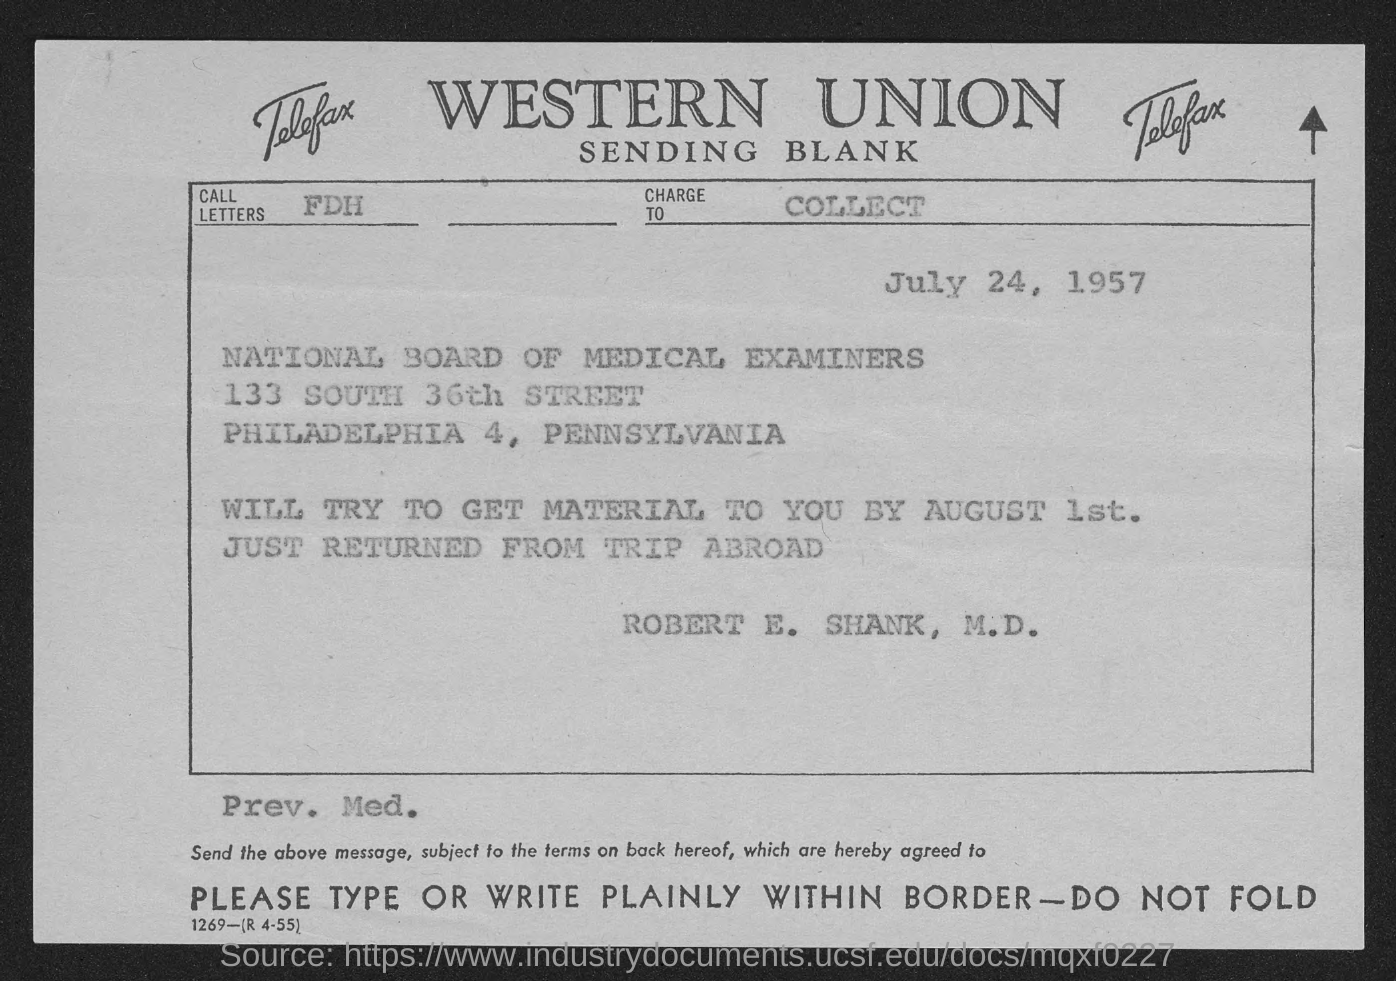Which firm is mentioned at the top of the page?
Make the answer very short. WESTERN UNION. Which board is mentioned?
Provide a short and direct response. NATIONAL BOARD OF MEDICAL EXAMINERS. From whom is the fax?
Ensure brevity in your answer.  Robert E. Shank, M.D. When is the document dated?
Offer a terse response. July 24, 1957. When will the material be sent?
Provide a succinct answer. By august 1st. 